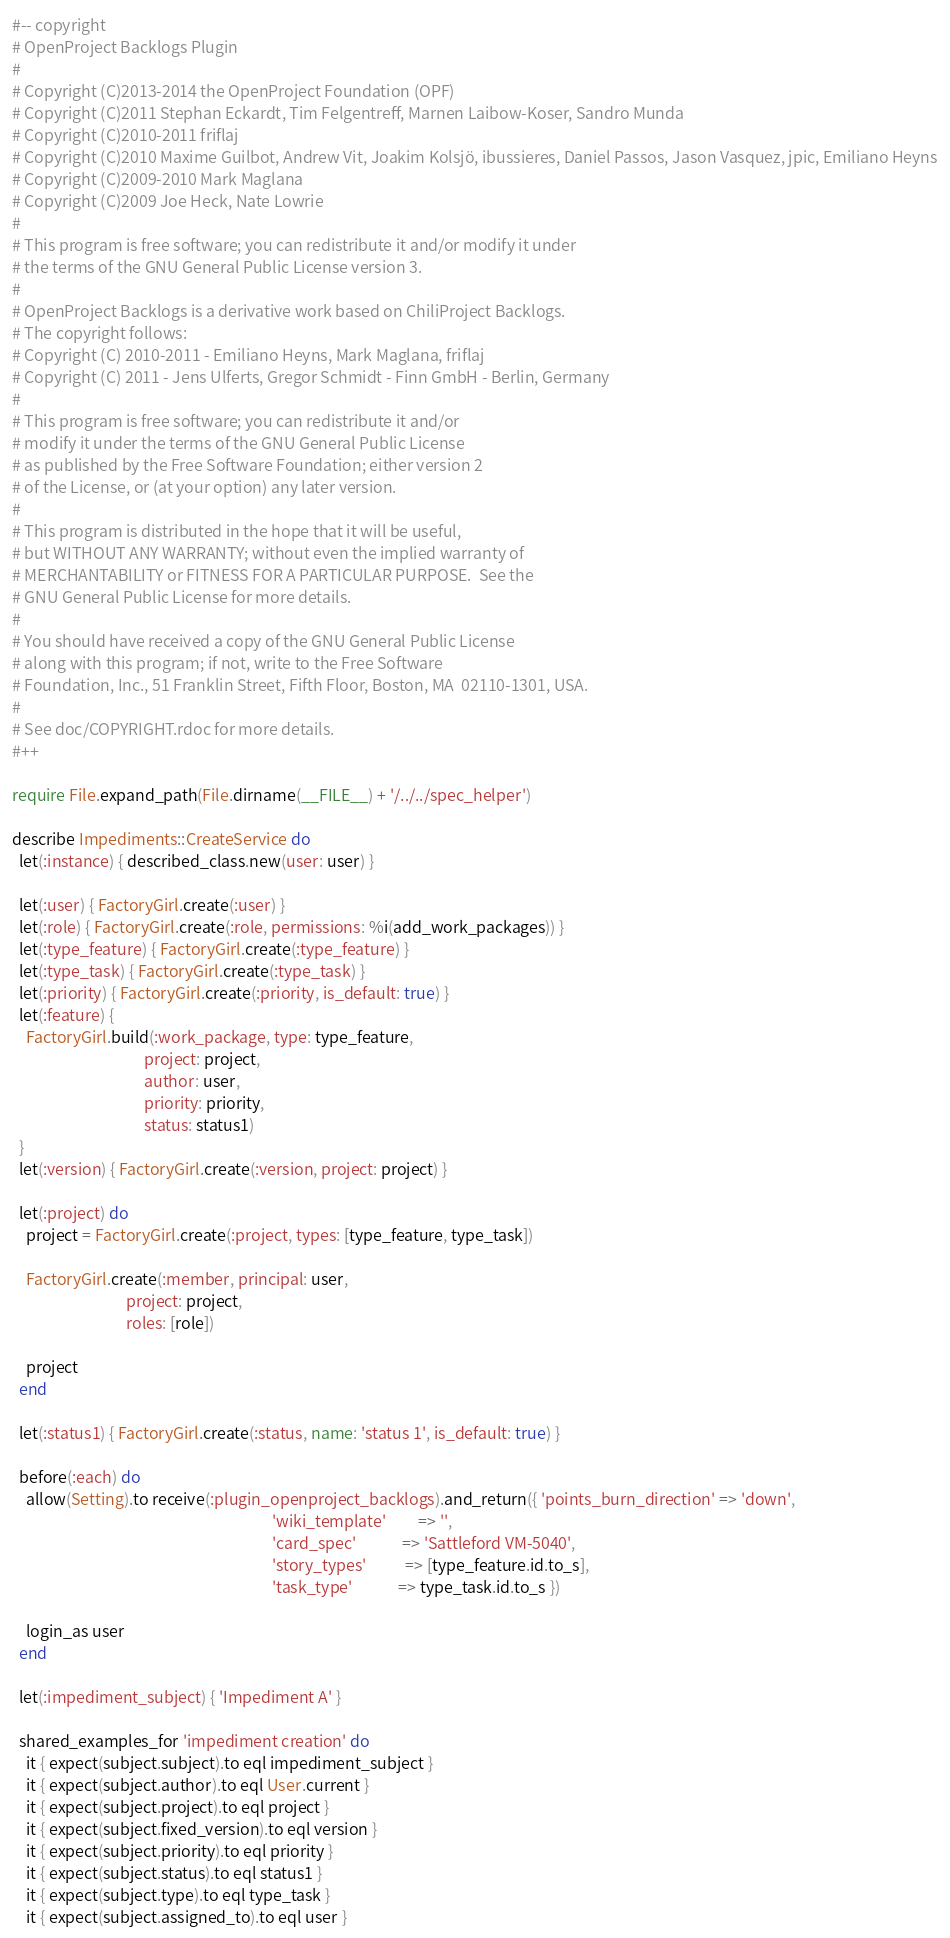<code> <loc_0><loc_0><loc_500><loc_500><_Ruby_>#-- copyright
# OpenProject Backlogs Plugin
#
# Copyright (C)2013-2014 the OpenProject Foundation (OPF)
# Copyright (C)2011 Stephan Eckardt, Tim Felgentreff, Marnen Laibow-Koser, Sandro Munda
# Copyright (C)2010-2011 friflaj
# Copyright (C)2010 Maxime Guilbot, Andrew Vit, Joakim Kolsjö, ibussieres, Daniel Passos, Jason Vasquez, jpic, Emiliano Heyns
# Copyright (C)2009-2010 Mark Maglana
# Copyright (C)2009 Joe Heck, Nate Lowrie
#
# This program is free software; you can redistribute it and/or modify it under
# the terms of the GNU General Public License version 3.
#
# OpenProject Backlogs is a derivative work based on ChiliProject Backlogs.
# The copyright follows:
# Copyright (C) 2010-2011 - Emiliano Heyns, Mark Maglana, friflaj
# Copyright (C) 2011 - Jens Ulferts, Gregor Schmidt - Finn GmbH - Berlin, Germany
#
# This program is free software; you can redistribute it and/or
# modify it under the terms of the GNU General Public License
# as published by the Free Software Foundation; either version 2
# of the License, or (at your option) any later version.
#
# This program is distributed in the hope that it will be useful,
# but WITHOUT ANY WARRANTY; without even the implied warranty of
# MERCHANTABILITY or FITNESS FOR A PARTICULAR PURPOSE.  See the
# GNU General Public License for more details.
#
# You should have received a copy of the GNU General Public License
# along with this program; if not, write to the Free Software
# Foundation, Inc., 51 Franklin Street, Fifth Floor, Boston, MA  02110-1301, USA.
#
# See doc/COPYRIGHT.rdoc for more details.
#++

require File.expand_path(File.dirname(__FILE__) + '/../../spec_helper')

describe Impediments::CreateService do
  let(:instance) { described_class.new(user: user) }

  let(:user) { FactoryGirl.create(:user) }
  let(:role) { FactoryGirl.create(:role, permissions: %i(add_work_packages)) }
  let(:type_feature) { FactoryGirl.create(:type_feature) }
  let(:type_task) { FactoryGirl.create(:type_task) }
  let(:priority) { FactoryGirl.create(:priority, is_default: true) }
  let(:feature) {
    FactoryGirl.build(:work_package, type: type_feature,
                                     project: project,
                                     author: user,
                                     priority: priority,
                                     status: status1)
  }
  let(:version) { FactoryGirl.create(:version, project: project) }

  let(:project) do
    project = FactoryGirl.create(:project, types: [type_feature, type_task])

    FactoryGirl.create(:member, principal: user,
                                project: project,
                                roles: [role])

    project
  end

  let(:status1) { FactoryGirl.create(:status, name: 'status 1', is_default: true) }

  before(:each) do
    allow(Setting).to receive(:plugin_openproject_backlogs).and_return({ 'points_burn_direction' => 'down',
                                                                         'wiki_template'         => '',
                                                                         'card_spec'             => 'Sattleford VM-5040',
                                                                         'story_types'           => [type_feature.id.to_s],
                                                                         'task_type'             => type_task.id.to_s })

    login_as user
  end

  let(:impediment_subject) { 'Impediment A' }

  shared_examples_for 'impediment creation' do
    it { expect(subject.subject).to eql impediment_subject }
    it { expect(subject.author).to eql User.current }
    it { expect(subject.project).to eql project }
    it { expect(subject.fixed_version).to eql version }
    it { expect(subject.priority).to eql priority }
    it { expect(subject.status).to eql status1 }
    it { expect(subject.type).to eql type_task }
    it { expect(subject.assigned_to).to eql user }</code> 